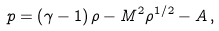<formula> <loc_0><loc_0><loc_500><loc_500>p = \left ( \gamma - 1 \right ) \rho - M ^ { 2 } \rho ^ { 1 / 2 } - A \, ,</formula> 